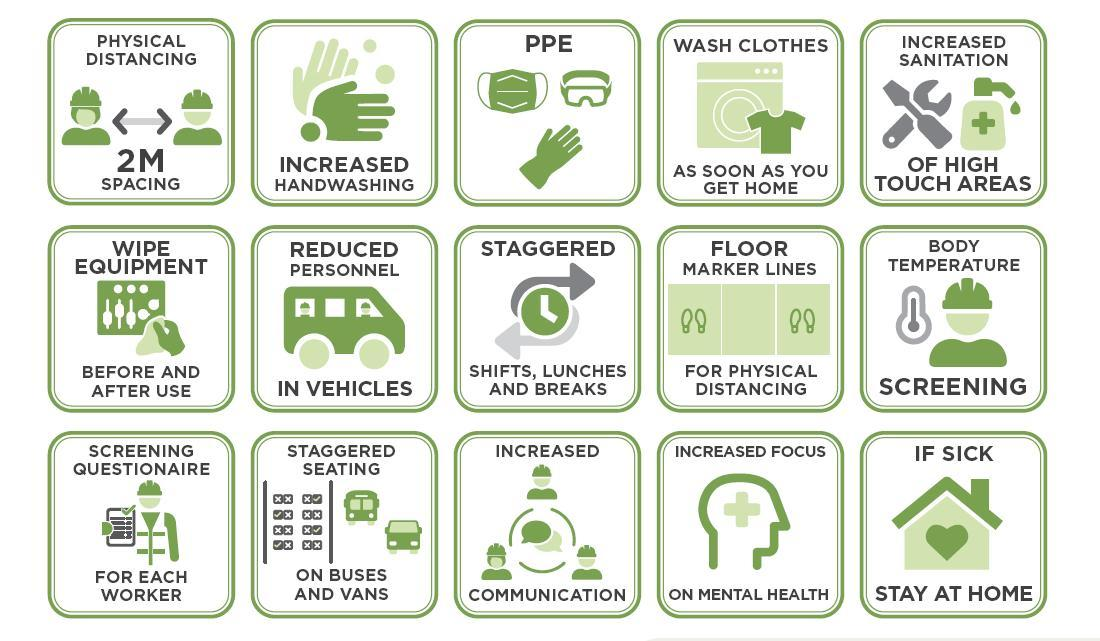On what matter should increased focus should be given?
Answer the question with a short phrase. on mental health How should shifts and lunch breaks be coordinated? staggered What includes masks, goggles and gloves? PPE What does a 2m spacing between people help to maintain? physical distancing what should a person do if he is sick? stay at home What should be wiped before and after use? equipment What should each worker be asked to complete and submit? screening questionnaire What is the purpose of floor marker lines in COVID-19 prevention? for physical distancing What type of seating arrangements can be made in buses and vans? staggered seating What preventive step can be taken on high touch areas? increased sanitation 